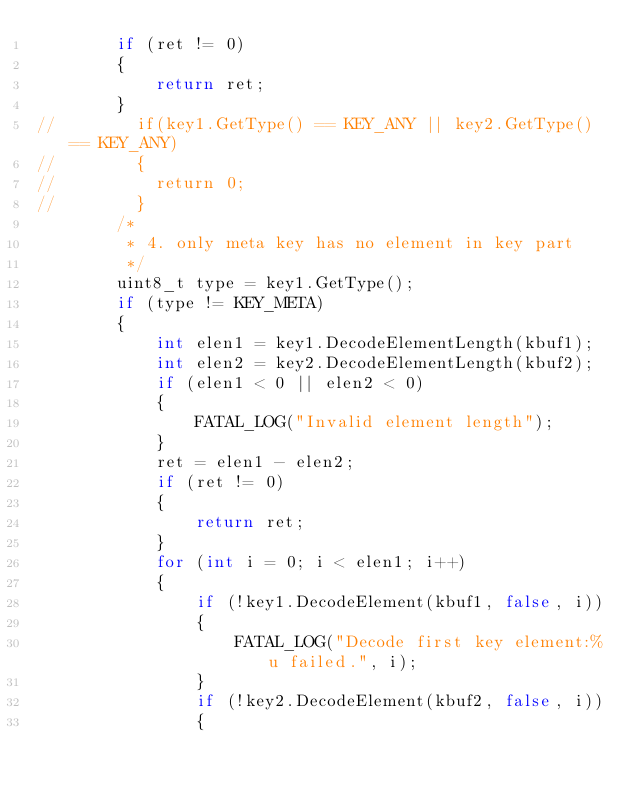Convert code to text. <code><loc_0><loc_0><loc_500><loc_500><_C++_>        if (ret != 0)
        {
            return ret;
        }
//        if(key1.GetType() == KEY_ANY || key2.GetType() == KEY_ANY)
//        {
//        	return 0;
//        }
        /*
         * 4. only meta key has no element in key part
         */
        uint8_t type = key1.GetType();
        if (type != KEY_META)
        {
            int elen1 = key1.DecodeElementLength(kbuf1);
            int elen2 = key2.DecodeElementLength(kbuf2);
            if (elen1 < 0 || elen2 < 0)
            {
                FATAL_LOG("Invalid element length");
            }
            ret = elen1 - elen2;
            if (ret != 0)
            {
                return ret;
            }
            for (int i = 0; i < elen1; i++)
            {
                if (!key1.DecodeElement(kbuf1, false, i))
                {
                    FATAL_LOG("Decode first key element:%u failed.", i);
                }
                if (!key2.DecodeElement(kbuf2, false, i))
                {</code> 